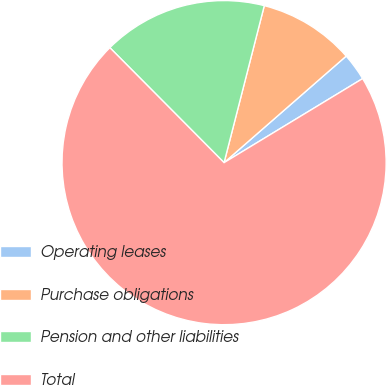Convert chart to OTSL. <chart><loc_0><loc_0><loc_500><loc_500><pie_chart><fcel>Operating leases<fcel>Purchase obligations<fcel>Pension and other liabilities<fcel>Total<nl><fcel>2.74%<fcel>9.59%<fcel>16.44%<fcel>71.23%<nl></chart> 